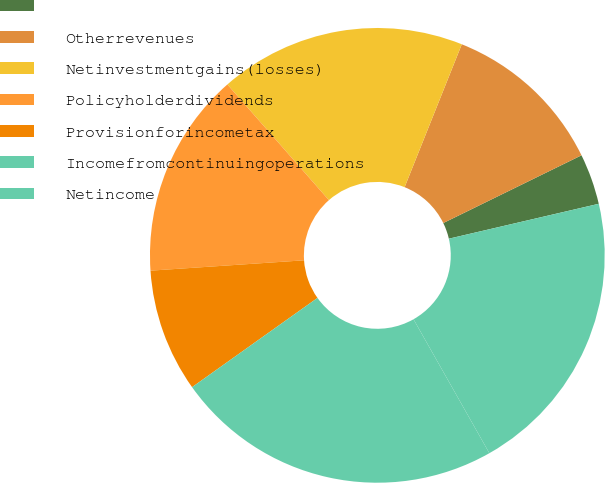<chart> <loc_0><loc_0><loc_500><loc_500><pie_chart><ecel><fcel>Otherrevenues<fcel>Netinvestmentgains(losses)<fcel>Policyholderdividends<fcel>Provisionforincometax<fcel>Incomefromcontinuingoperations<fcel>Netincome<nl><fcel>3.61%<fcel>11.69%<fcel>17.52%<fcel>14.61%<fcel>8.77%<fcel>23.36%<fcel>20.44%<nl></chart> 